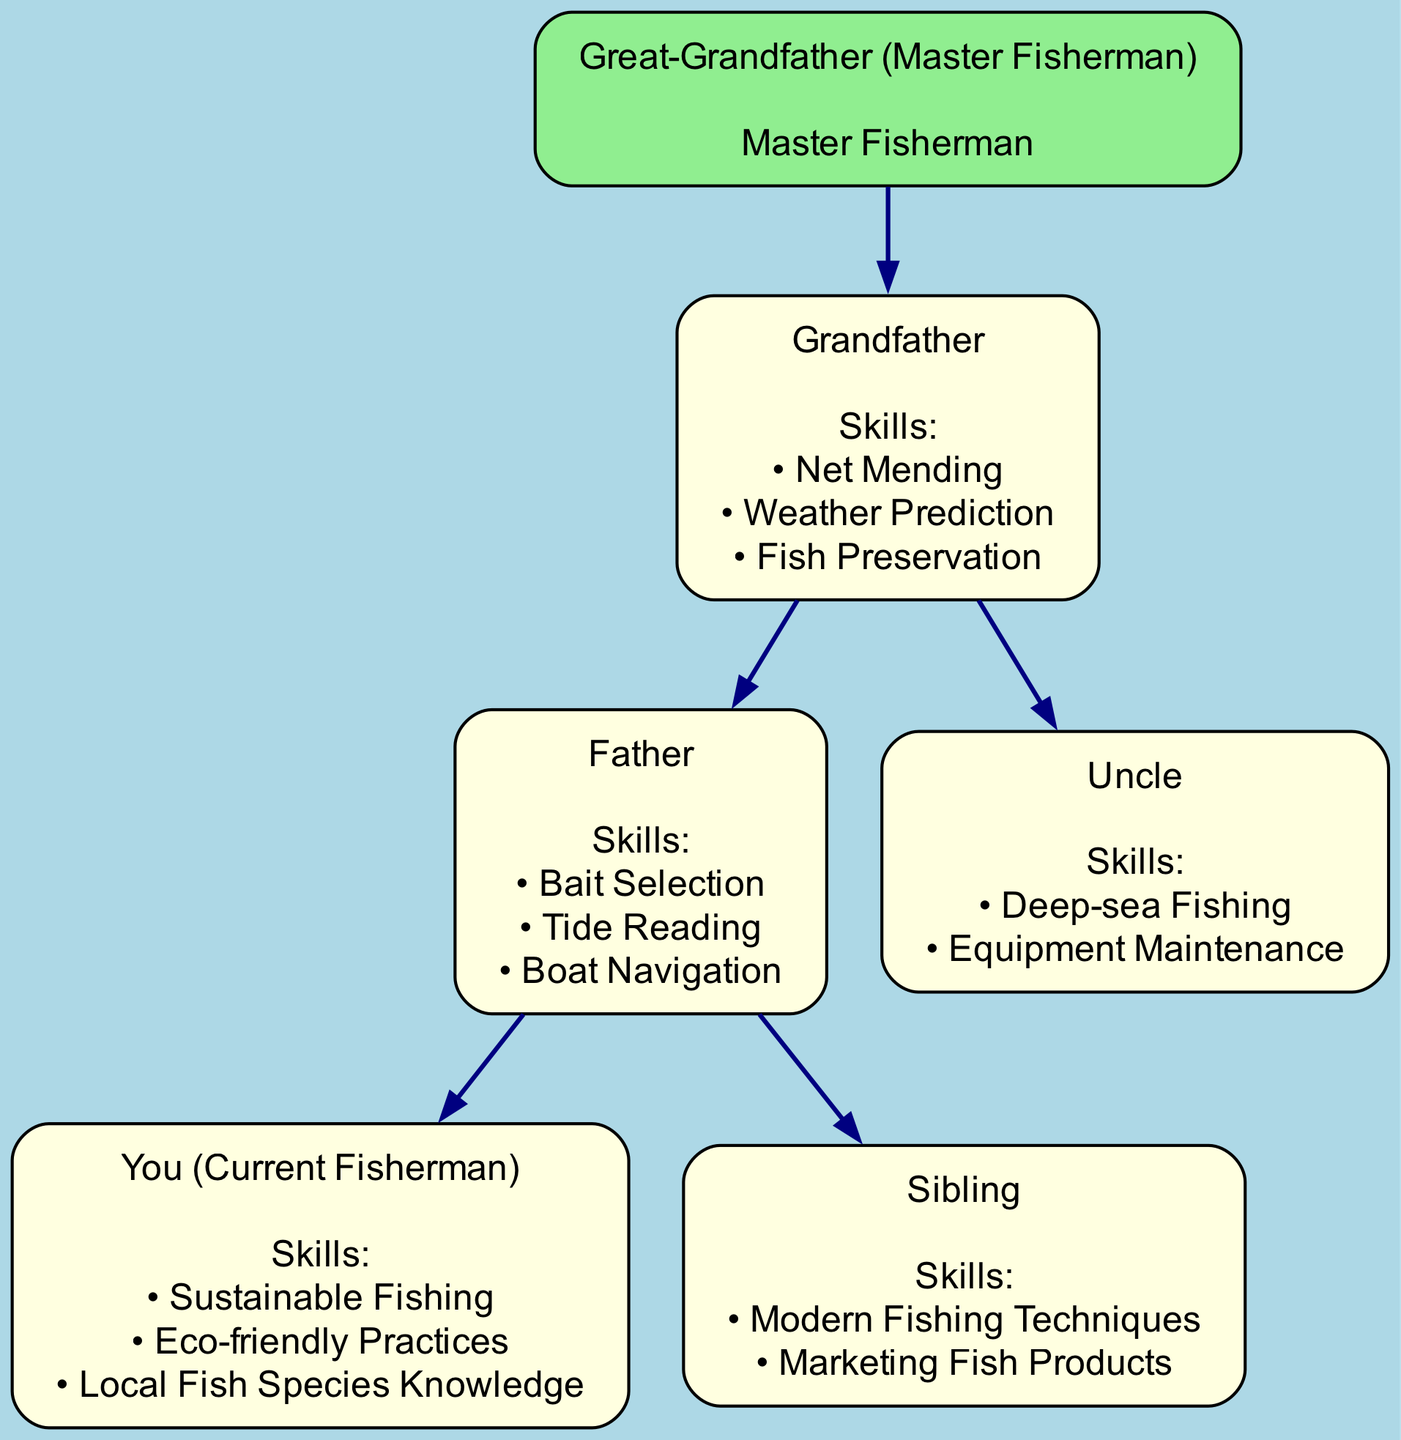What is the highest level of the family tree? The highest level in the family tree is represented by the root node, which shows the "Great-Grandfather (Master Fisherman)." Therefore, the answer identifies this individual as the original source of fishing knowledge in the lineage.
Answer: Great-Grandfather (Master Fisherman) How many skills does the Father have? The Father, who is a part of the second generation, has three skills listed: "Bait Selection," "Tide Reading," and "Boat Navigation." The answer reflects the count of skills displayed under the Father's node.
Answer: 3 Who is the uncle? The uncle in the diagram is labeled simply as "Uncle," without any additional name or identifier. This answer refers to the presence of this family member in relation to the other nodes.
Answer: Uncle What skill is shared by both the Grandfather and the Father? Both the Grandfather and the Father possess a deep understanding of fishing; however, the question specifically targets the skills. The Grandfather does not share an exact skill in a direct manner; thus, this question requires careful attention to their respective skills. The Grandfather's skills do not intersect with the Father's, indicating that the value returned should ensure clarity.
Answer: None Which generation does "You (Current Fisherman)" belong to? The "You (Current Fisherman)" appears in the third generation of the family tree, beneath the Father, indicating the direct descendant line. This answer captures the generational lineage accurately.
Answer: Third generation What is one skill practiced by "You (Current Fisherman)"? In the diagram, the "You" node lists three skills, one of which can be identified from the options available. For instance, "Sustainable Fishing" is one of the mentioned skills in the skills list for the current fisherman.
Answer: Sustainable Fishing How many children does the Grandfather have? The Grandfather node shows that there are two children, namely the Father and the Uncle. The straightforward concept captures how many direct descendants the Grandfather has.
Answer: 2 What fishing skill does the Sibling focus on? The Sibling node highlights "Modern Fishing Techniques" as one of the skills they specialize in, which indicates their approach to fishing compared to the traditional knowledge passed down. This answer stems directly from understanding the displayed skills for this specific node.
Answer: Modern Fishing Techniques What color represents the root node in the diagram? The root node, which showcases the "Great-Grandfather (Master Fisherman)," is colored light green. This distinctive color choice can be observed in the design attributed to the root, making the answer clear.
Answer: Light green 